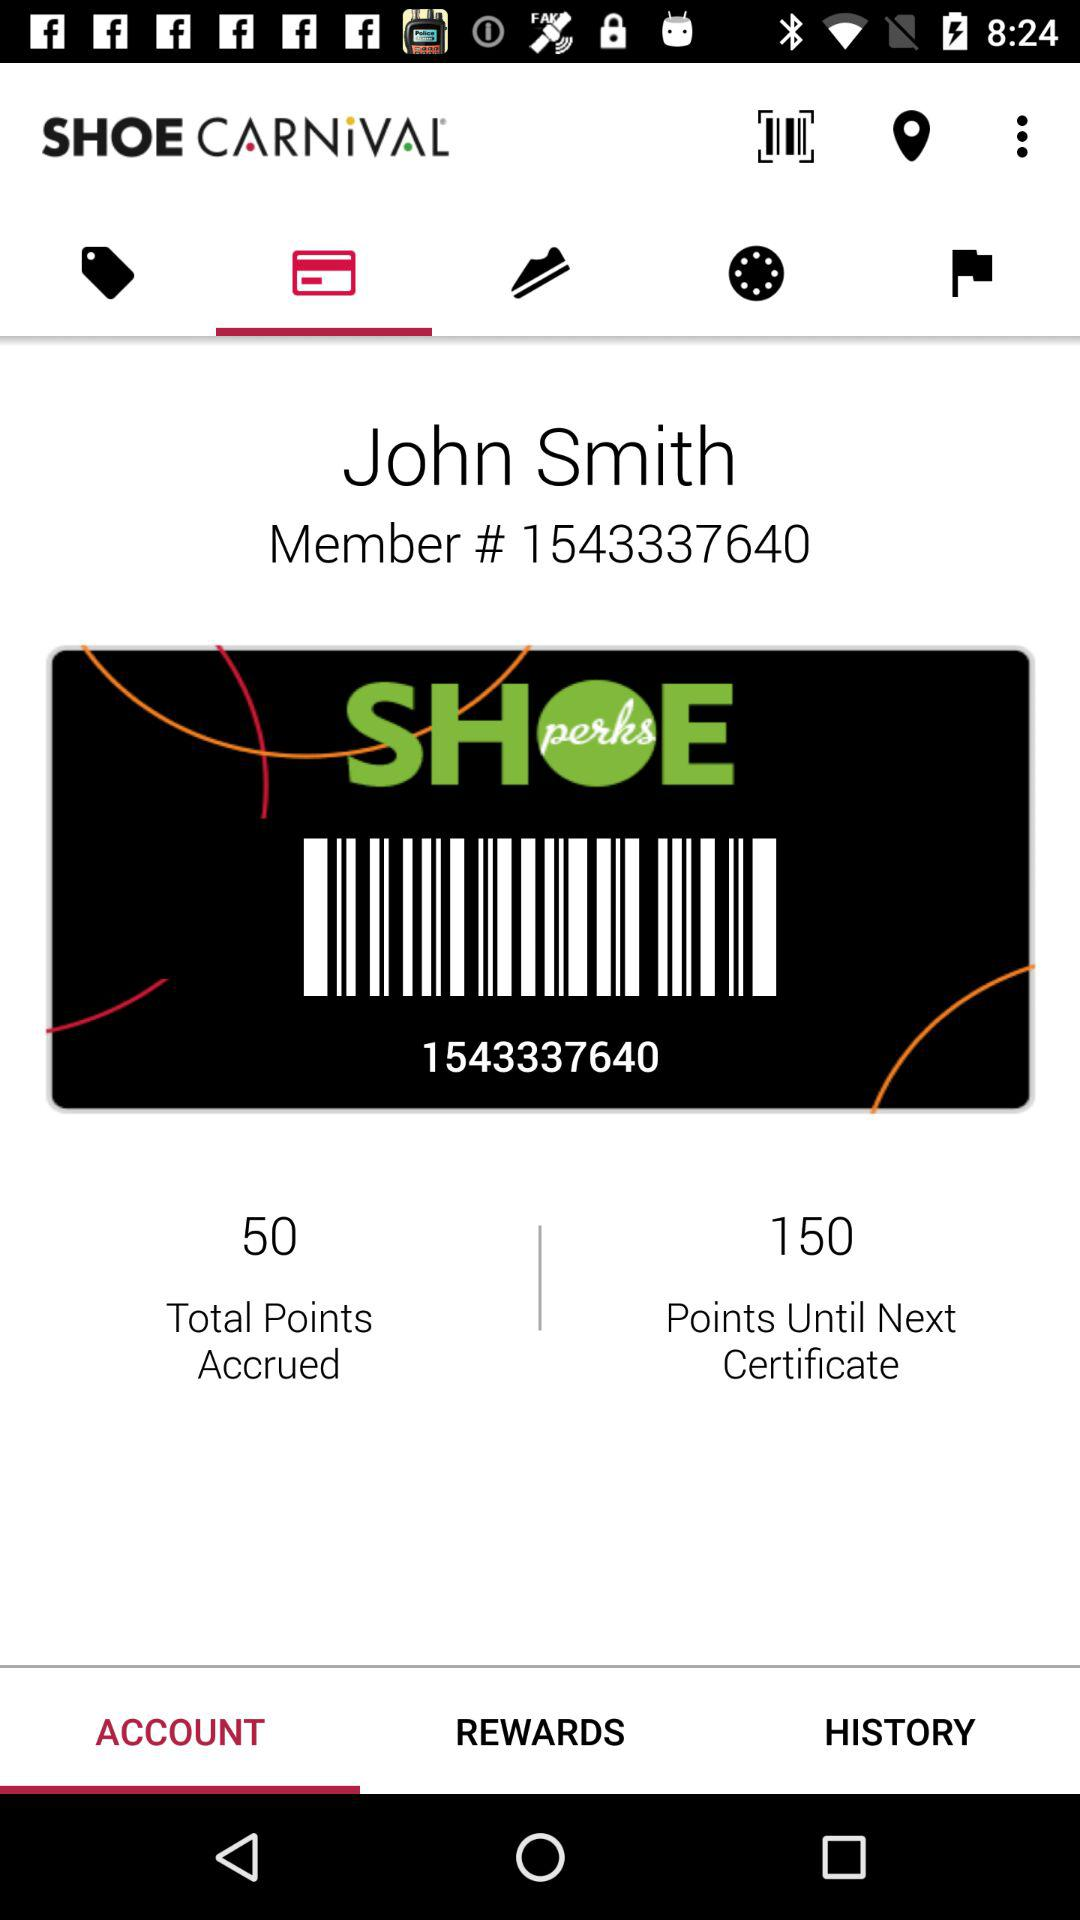How many points have I accrued?
Answer the question using a single word or phrase. 50 